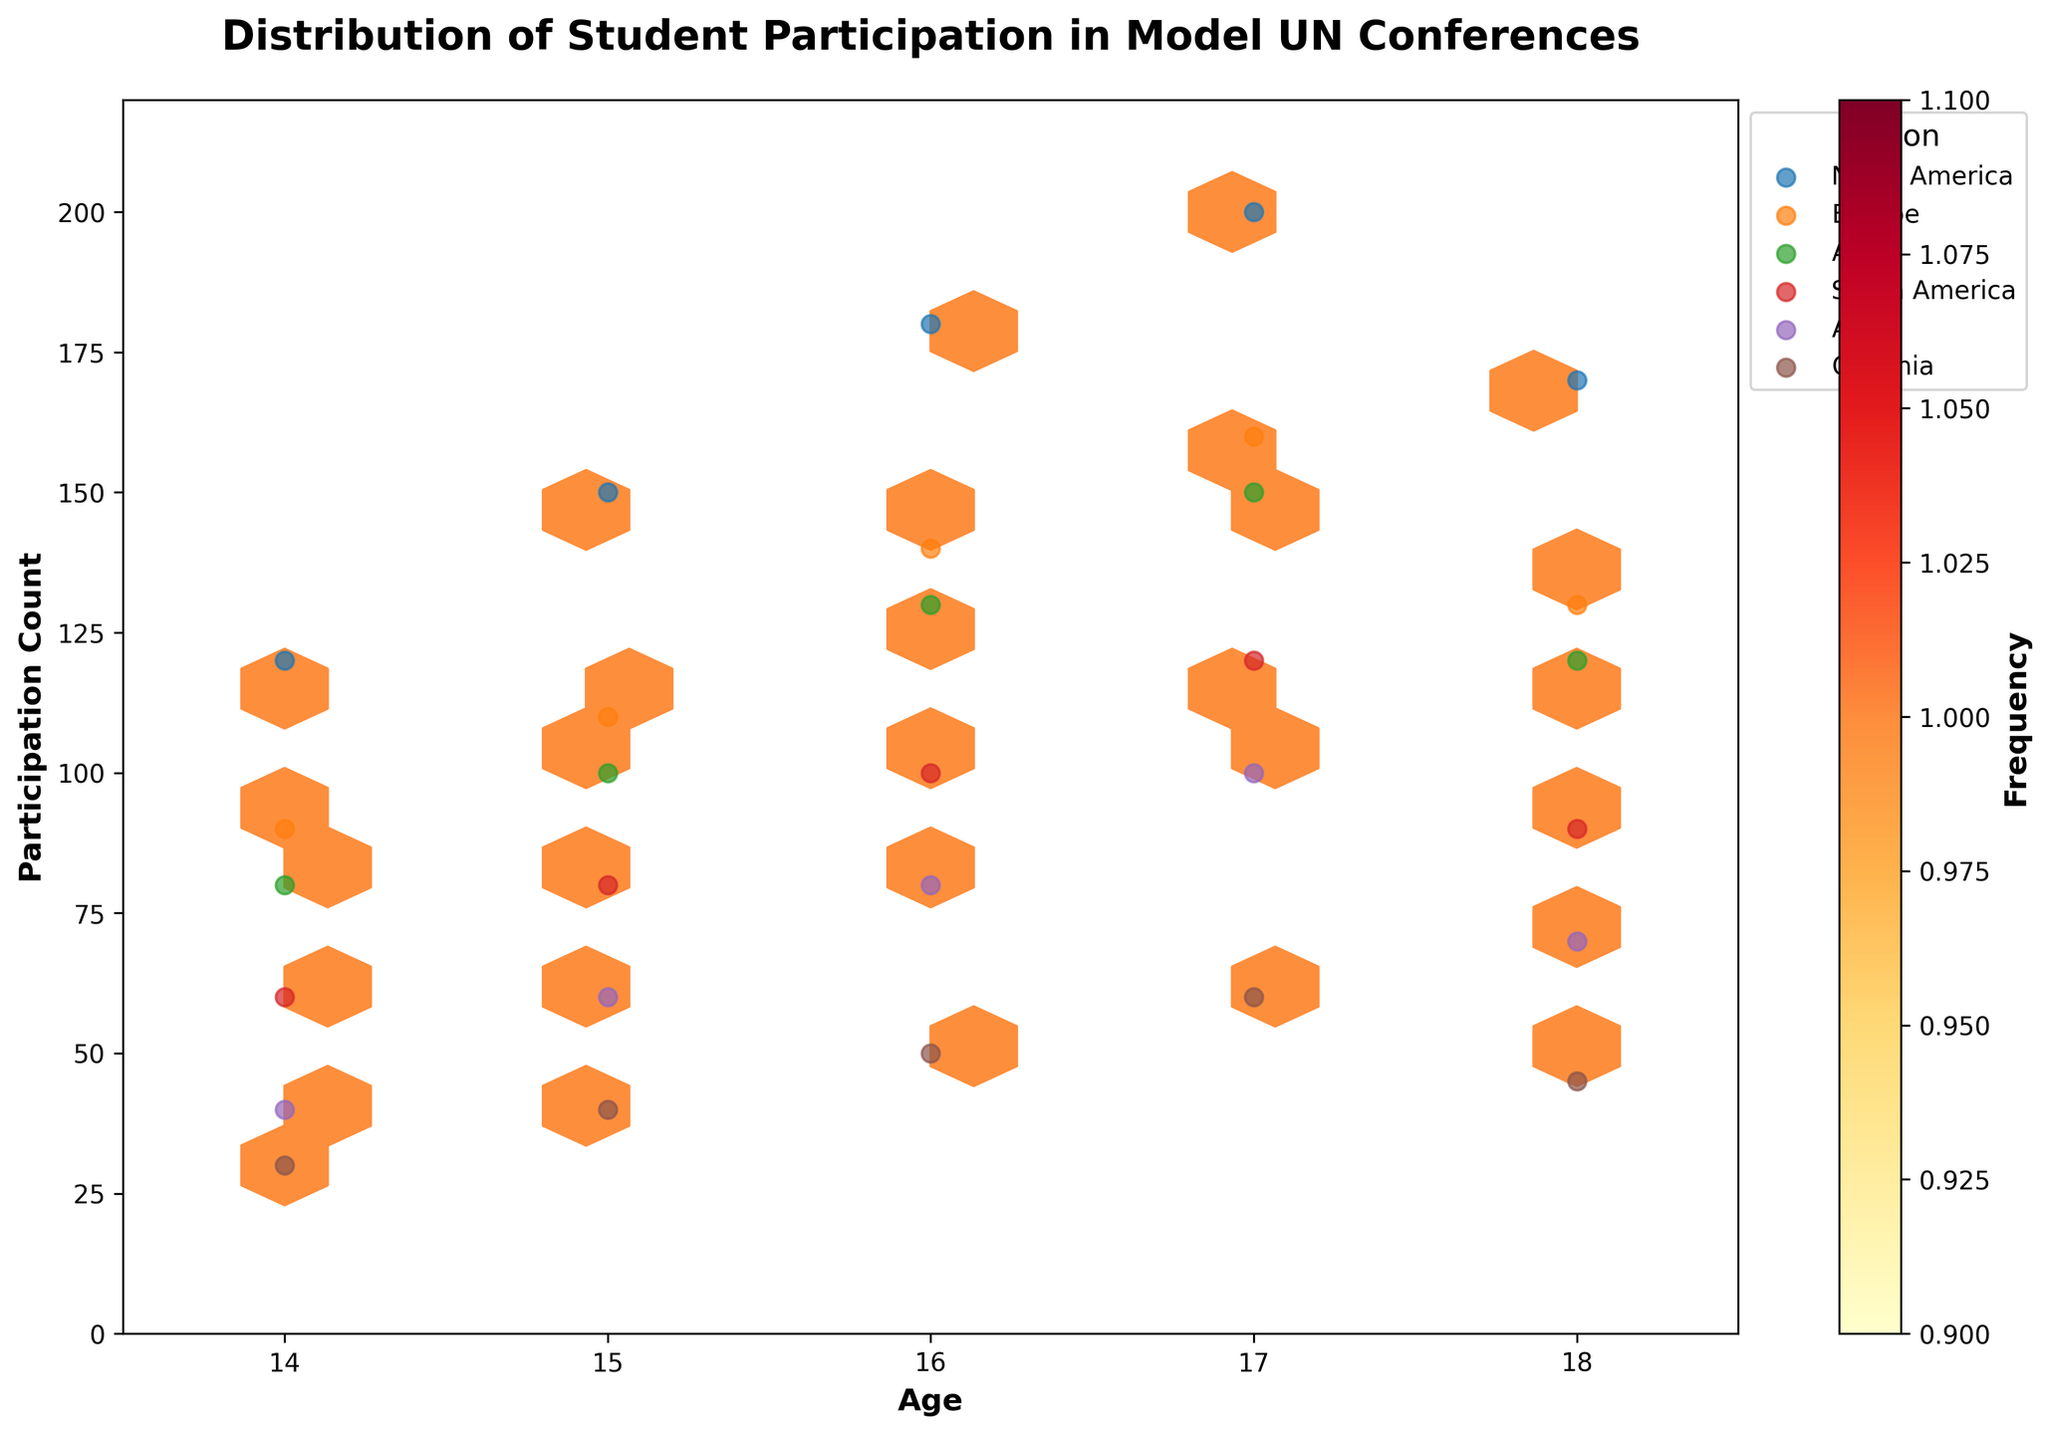What is the title of the figure? The title is located at the top of the plot. It reads: "Distribution of Student Participation in Model UN Conferences".
Answer: Distribution of Student Participation in Model UN Conferences What is the age group with the highest participation count in North America? Look for the scatter points labeled "North America" and identify the age group with the highest y-value (Participation Count). The highest count in North America is for age 17 with a participation count of 200.
Answer: 17 How many regions are represented in the plot? The legend on the plot shows all the regions represented. Counting the unique region labels in the legend, there are six regions.
Answer: Six What is the range of ages displayed on the x-axis? The x-axis is labeled "Age" and shows the range from the minimum to maximum tick values. The axis ranges from 13.5 to 18.5.
Answer: 13.5 to 18.5 In which region does the participation count drop for age 18 compared to age 17? Examine the scatter points for each region. The participation counts drop from age 17 to age 18 in North America, Europe, Asia, South America, and Africa. Oceania also has a drop from age 17 to 18.
Answer: Multiple regions drop, including North America What is the average participation count for students aged 16 across all regions? Look at the participation counts for age 16 in each of the six regions: 180, 140, 130, 100, 80, 50. Add them up and divide by the number of regions (6). (180 + 140 + 130 + 100 + 80 + 50) / 6 ≈ 680 / 6 = 113.33.
Answer: 113.33 Which region has the lowest participation count for age 14? Look at the scatter points for age 14 in each region. The lowest participation count is for Oceania with a count of 30.
Answer: Oceania What is the most common participation count depicted in the hexagonal bins? The color bar indicates frequency, and the hexagon bins with the highest frequency are the ones with the brightest color. The common participation count can be estimated by looking at the center of the densest hexagons. Participation counts around 140 to 160 are most frequent.
Answer: 140-160 Is there a trend in participation counts as students get older? Observe the scatter points and their overall pattern. For most regions, participation counts generally increase with age until around 17, then decrease slightly at age 18.
Answer: Increase until 17, then decrease How does the participation count for age 15 in Africa compare to age 15 in Asia? Observe the scatter points for age 15 in both Africa and Asia. Age 15 in Africa has a participation count of 60, whereas in Asia it is 100. Compare the two counts directly.
Answer: Asia's count is higher 